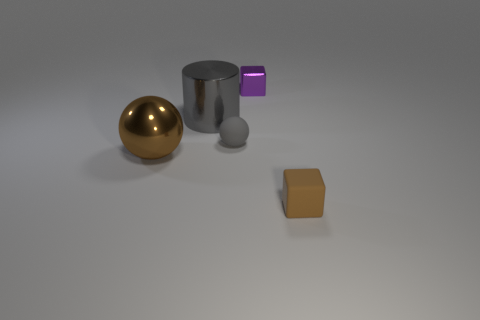Add 2 small green things. How many objects exist? 7 Subtract all blocks. How many objects are left? 3 Add 4 tiny green balls. How many tiny green balls exist? 4 Subtract 0 blue cylinders. How many objects are left? 5 Subtract all brown shiny things. Subtract all brown metal cylinders. How many objects are left? 4 Add 1 metal objects. How many metal objects are left? 4 